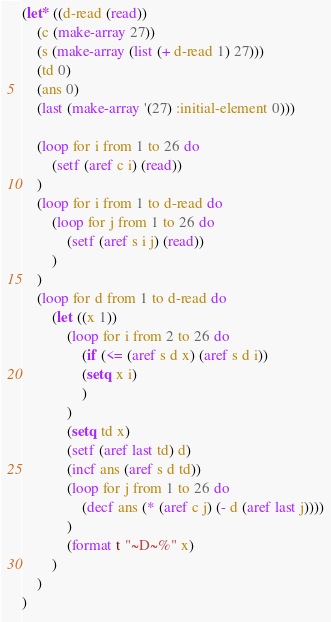Convert code to text. <code><loc_0><loc_0><loc_500><loc_500><_Lisp_>(let* ((d-read (read))
    (c (make-array 27))
    (s (make-array (list (+ d-read 1) 27)))
    (td 0)
    (ans 0)
    (last (make-array '(27) :initial-element 0)))

    (loop for i from 1 to 26 do
        (setf (aref c i) (read))
    )
    (loop for i from 1 to d-read do
        (loop for j from 1 to 26 do
            (setf (aref s i j) (read))
        )
    )
    (loop for d from 1 to d-read do
        (let ((x 1))
            (loop for i from 2 to 26 do
                (if (<= (aref s d x) (aref s d i))
                (setq x i)
                )
            )
            (setq td x)
            (setf (aref last td) d)
            (incf ans (aref s d td))
            (loop for j from 1 to 26 do
                (decf ans (* (aref c j) (- d (aref last j))))
            )
            (format t "~D~%" x)
        )
    )
)</code> 